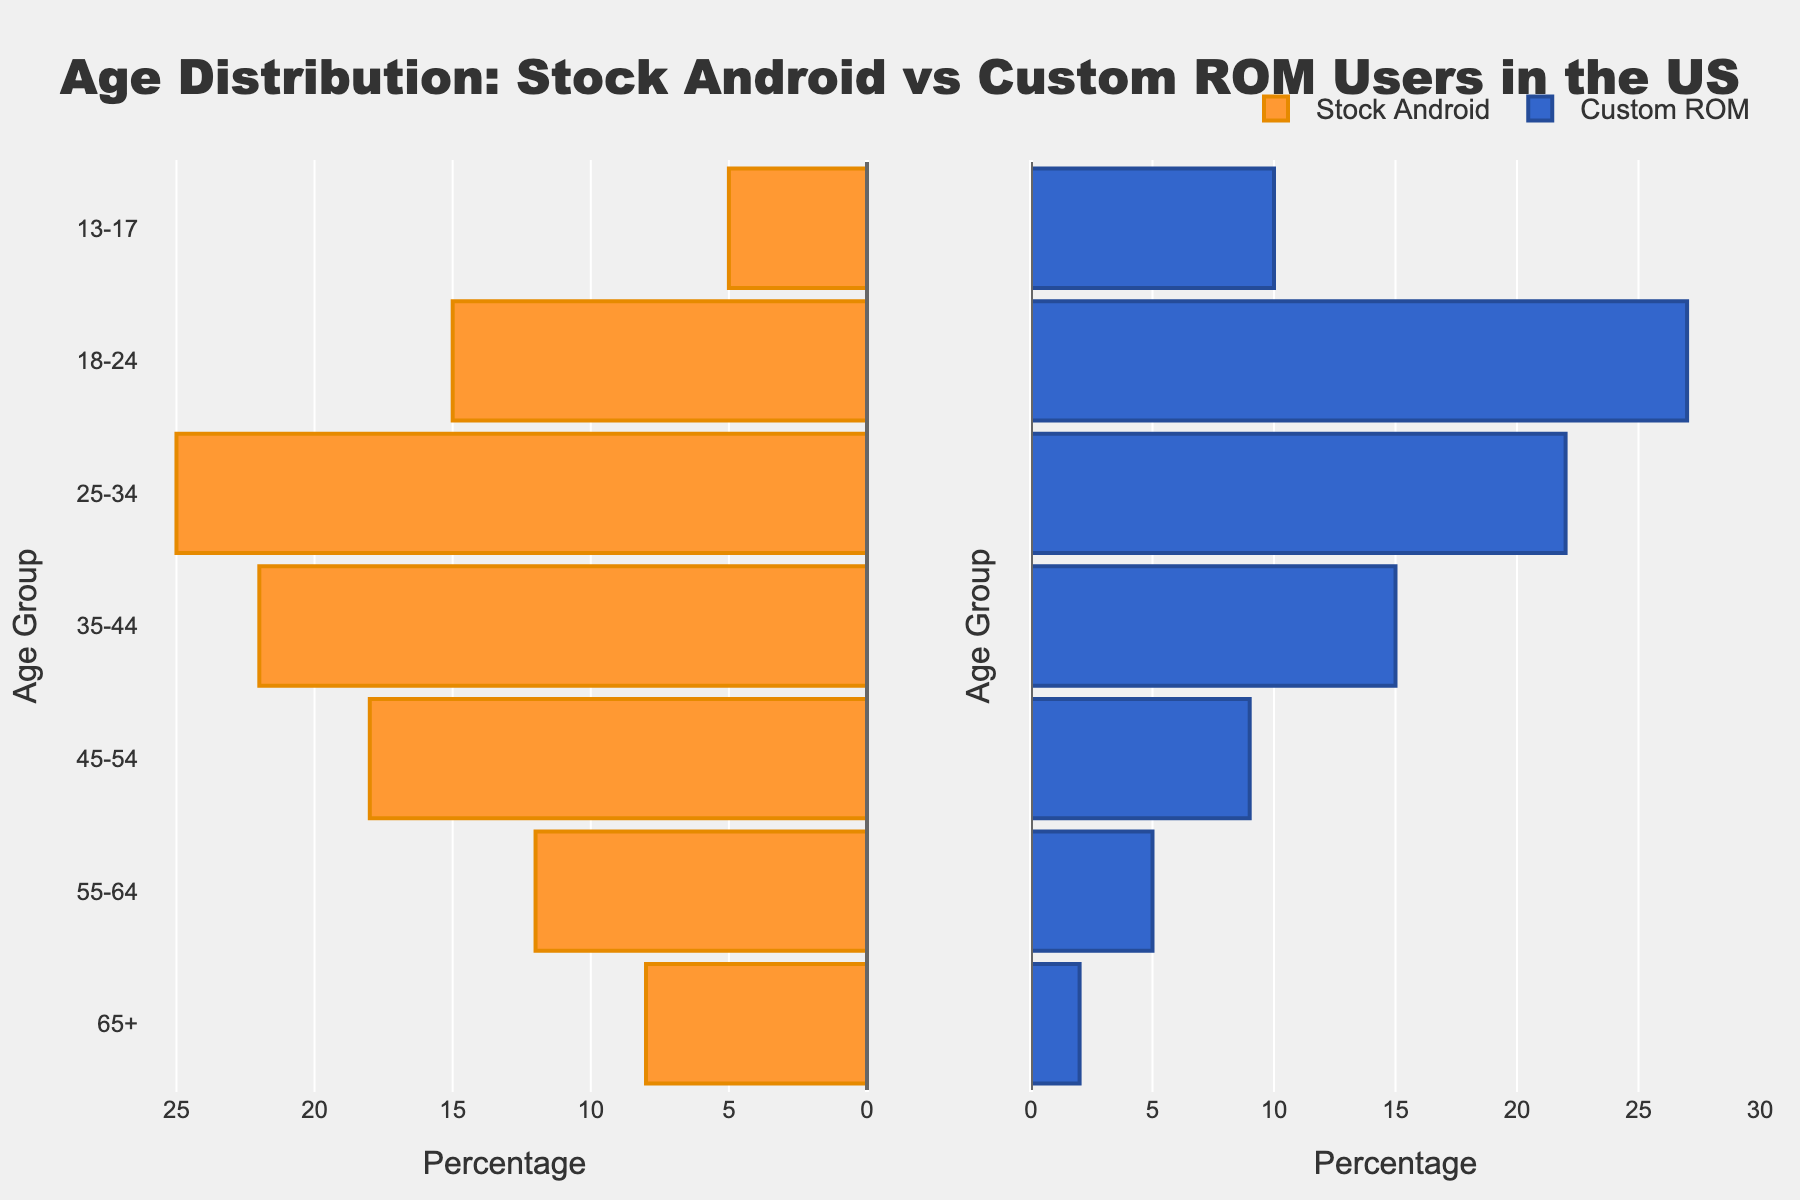Which age group has the highest percentage of Custom ROM users? The age group 18-24 has 27%, which is the highest for Custom ROM users.
Answer: 18-24 What is the title of the figure? The title is centered at the top of the figure and reads 'Age Distribution: Stock Android vs Custom ROM Users in the US'.
Answer: Age Distribution: Stock Android vs Custom ROM Users in the US Which age group has the lowest percentage of Stock Android users? The age group 13-17 has 5%, which is the lowest for Stock Android users.
Answer: 13-17 How does the percentage of Stock Android users in the 25-34 age group compare to Custom ROM users in the same age group? The percentage of Stock Android users in the 25-34 age group is 25%, while for Custom ROM users it is 22%. Therefore, Stock Android has a higher percentage.
Answer: Stock Android has a higher percentage What is the sum of percentages for Stock Android users in the age groups 55-64 and 65+? The percentage for 55-64 age group is 12% and for 65+ age group is 8%. Summing them gives 12% + 8% = 20%.
Answer: 20% In which age group is the difference in percentages between Stock Android users and Custom ROM users the highest? The age group 65+ shows the highest difference with Stock Android at 8% and Custom ROM at 2%, resulting in a difference of 6%.
Answer: 65+ What percentage of Custom ROM users fall within the 45-64 age range? For the 45-54 age group, it is 9%, and for the 55-64 age group, it is 5%. Summing these percentages gives 9% + 5% = 14%.
Answer: 14% How are the y-axes labeled in this figure? The y-axes are labeled with age groups: 65+, 55-64, 45-54, 35-44, 25-34, 18-24, and 13-17.
Answer: Age groups Which age group has the most balanced distribution between Stock Android and Custom ROM users? The 25-34 age group has 25% Stock Android users and 22% Custom ROM users, making it the most balanced distribution.
Answer: 25-34 What is the range of values displayed on the x-axis? The x-axis ranges from 0 to 30, with tick marks at intervals of 5%.
Answer: 0 to 30 